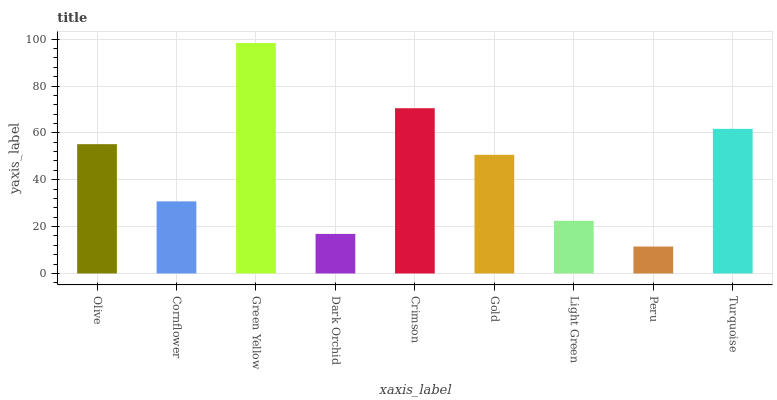Is Peru the minimum?
Answer yes or no. Yes. Is Green Yellow the maximum?
Answer yes or no. Yes. Is Cornflower the minimum?
Answer yes or no. No. Is Cornflower the maximum?
Answer yes or no. No. Is Olive greater than Cornflower?
Answer yes or no. Yes. Is Cornflower less than Olive?
Answer yes or no. Yes. Is Cornflower greater than Olive?
Answer yes or no. No. Is Olive less than Cornflower?
Answer yes or no. No. Is Gold the high median?
Answer yes or no. Yes. Is Gold the low median?
Answer yes or no. Yes. Is Turquoise the high median?
Answer yes or no. No. Is Turquoise the low median?
Answer yes or no. No. 